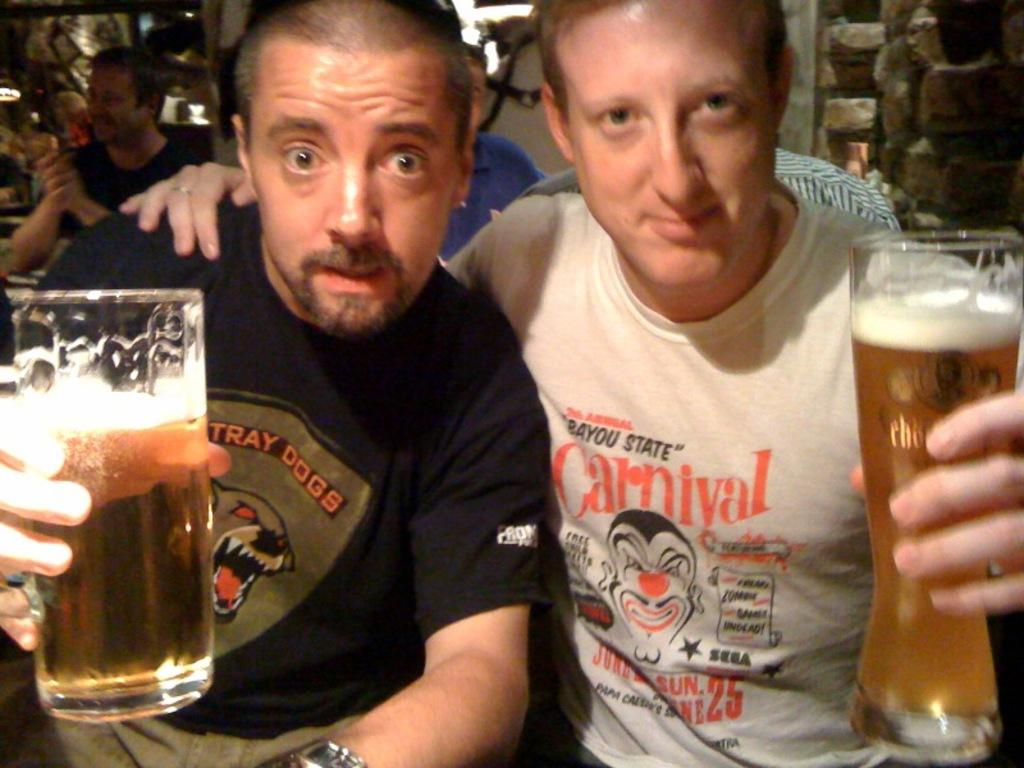How many men are in the image? There are two men in the image. What are the men doing in the image? The men are sitting in the image. What are the men holding in their hands? The men are holding wine glasses in their hands. What is inside the wine glasses? There is wine in the wine glasses. Can you describe the people in the background of the image? The people in the background of the image are also sitting. What type of liquid is being ordered by the men in the image? The men are not ordering any liquid in the image; they are holding wine glasses with wine. Is there any milk present in the image? There is no milk present in the image. 